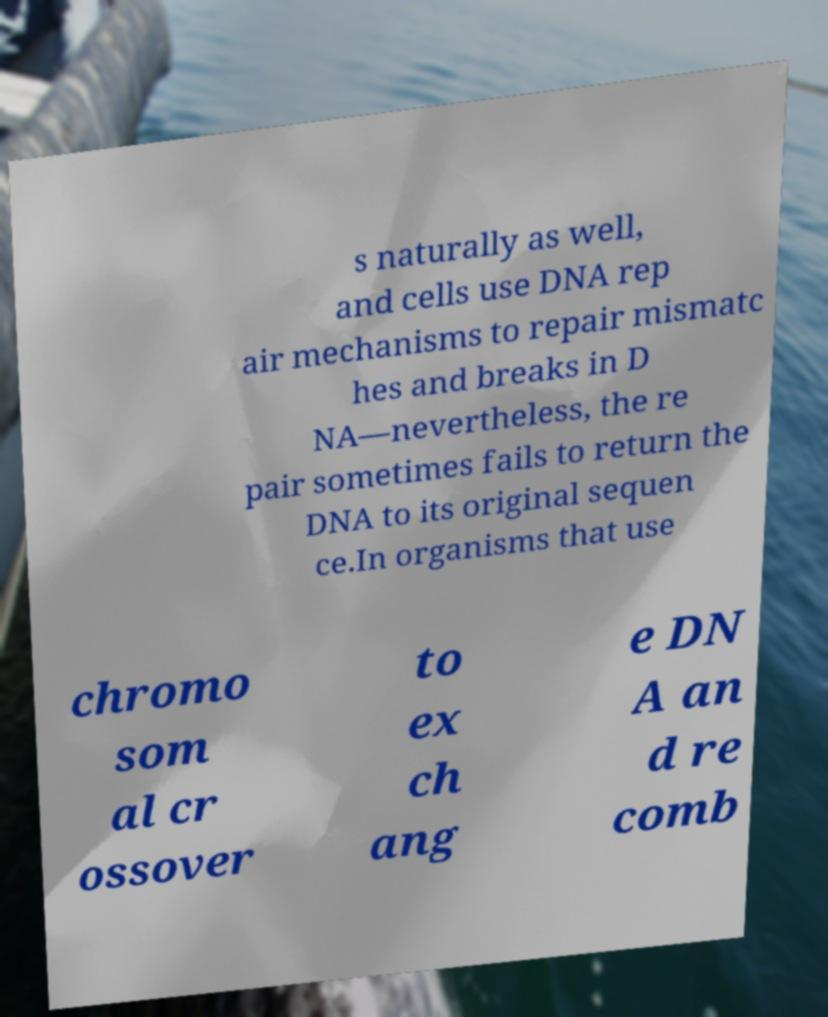There's text embedded in this image that I need extracted. Can you transcribe it verbatim? s naturally as well, and cells use DNA rep air mechanisms to repair mismatc hes and breaks in D NA—nevertheless, the re pair sometimes fails to return the DNA to its original sequen ce.In organisms that use chromo som al cr ossover to ex ch ang e DN A an d re comb 